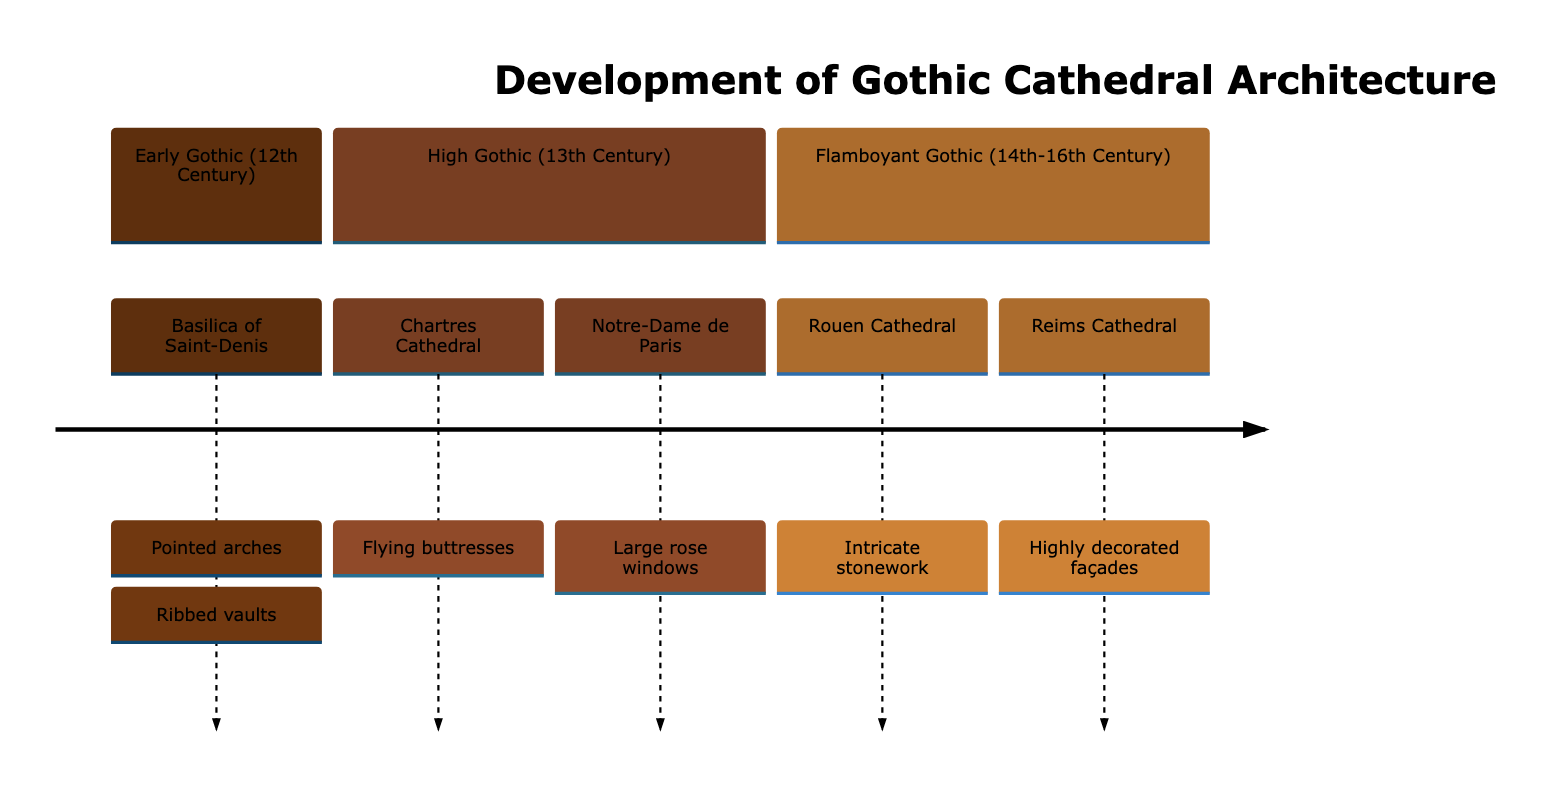What architectural feature characterizes the Basilica of Saint-Denis? The Basilica of Saint-Denis is characterized by pointed arches, which are mentioned in the section describing Early Gothic architecture. This feature is fundamental to the development of Gothic style.
Answer: Pointed arches Which cathedral is associated with flying buttresses? Flying buttresses are specifically associated with Chartres Cathedral in the High Gothic section of the diagram, indicating its architectural significance during this period.
Answer: Chartres Cathedral How many sections are depicted in the diagram? The diagram contains three distinct sections: Early Gothic, High Gothic, and Flamboyant Gothic. This is evident in the timeline structure that organizes the architectural evolution.
Answer: Three What is the primary architectural element of Reims Cathedral? Reims Cathedral is noted for its highly decorated façades as highlighted in the Flamboyant Gothic section, showcasing the intricate detailing characteristic of that period.
Answer: Highly decorated façades Which century is the Flamboyant Gothic period associated with? The Flamboyant Gothic period is associated with the 14th to 16th centuries as specified in the timeline section indicating the evolution of Gothic architecture.
Answer: 14th-16th Century What major architectural advance is featured in Notre-Dame de Paris? Notre-Dame de Paris features large rose windows, indicating a significant architectural advance during the High Gothic period, as indicated in that section of the diagram.
Answer: Large rose windows What does the diagram illustrate about the evolution of cathedral architecture? The diagram illustrates the chronological development of Gothic cathedral architecture, showing how features changed over time and providing specific examples of significant cathedrals for each period.
Answer: Evolution of Gothic cathedral architecture Which cathedral is mentioned under the Early Gothic section? The Basilica of Saint-Denis is mentioned in the Early Gothic section, marking its importance as an early example of Gothic architecture with its distinctive features.
Answer: Basilica of Saint-Denis 